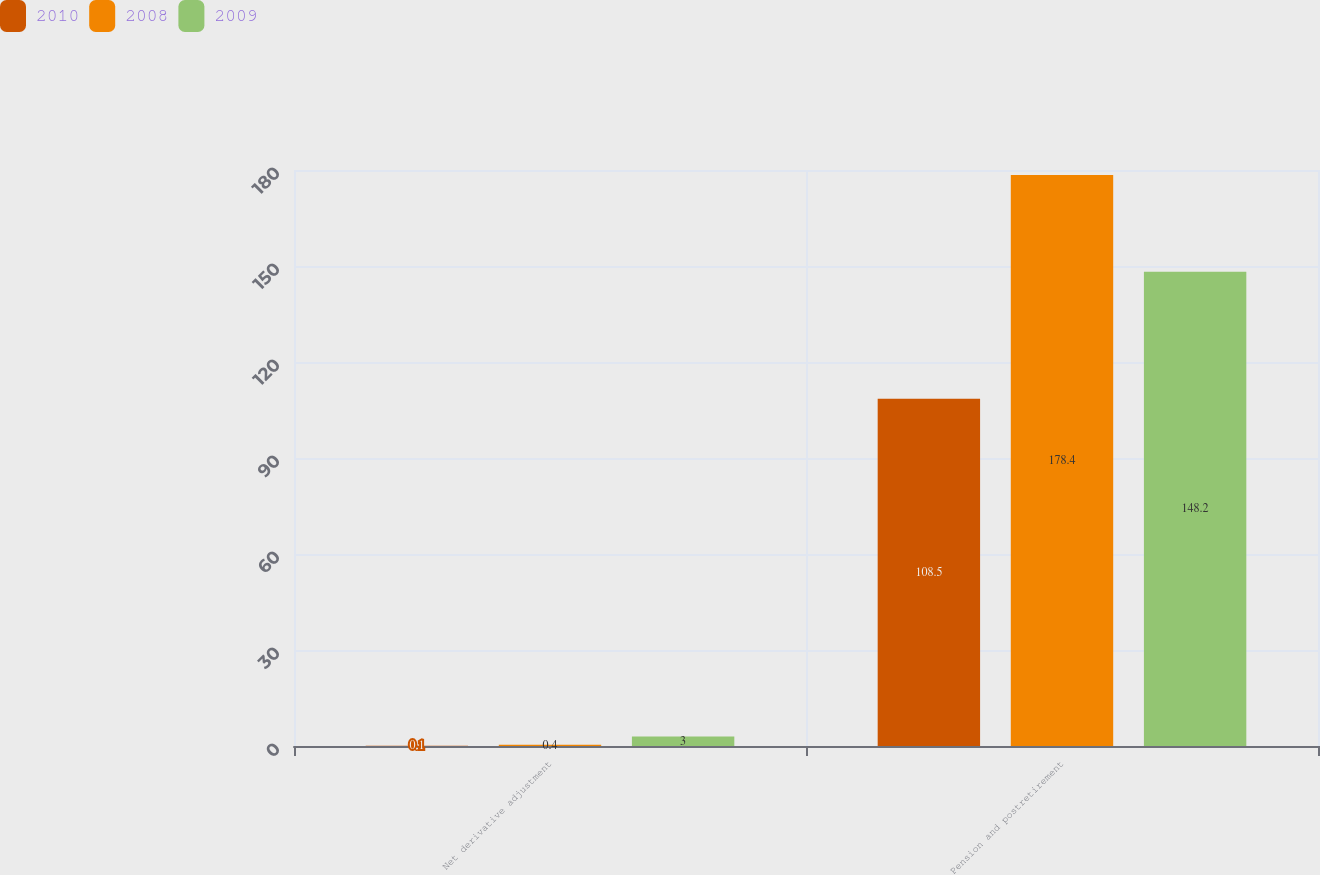Convert chart. <chart><loc_0><loc_0><loc_500><loc_500><stacked_bar_chart><ecel><fcel>Net derivative adjustment<fcel>Pension and postretirement<nl><fcel>2010<fcel>0.1<fcel>108.5<nl><fcel>2008<fcel>0.4<fcel>178.4<nl><fcel>2009<fcel>3<fcel>148.2<nl></chart> 